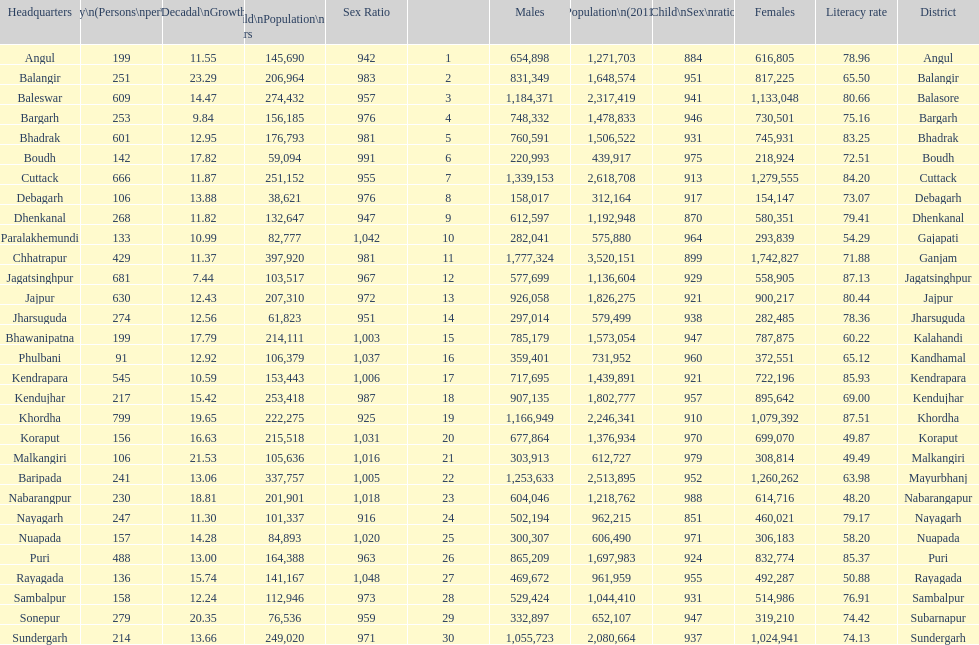What city is last in literacy? Nabarangapur. 